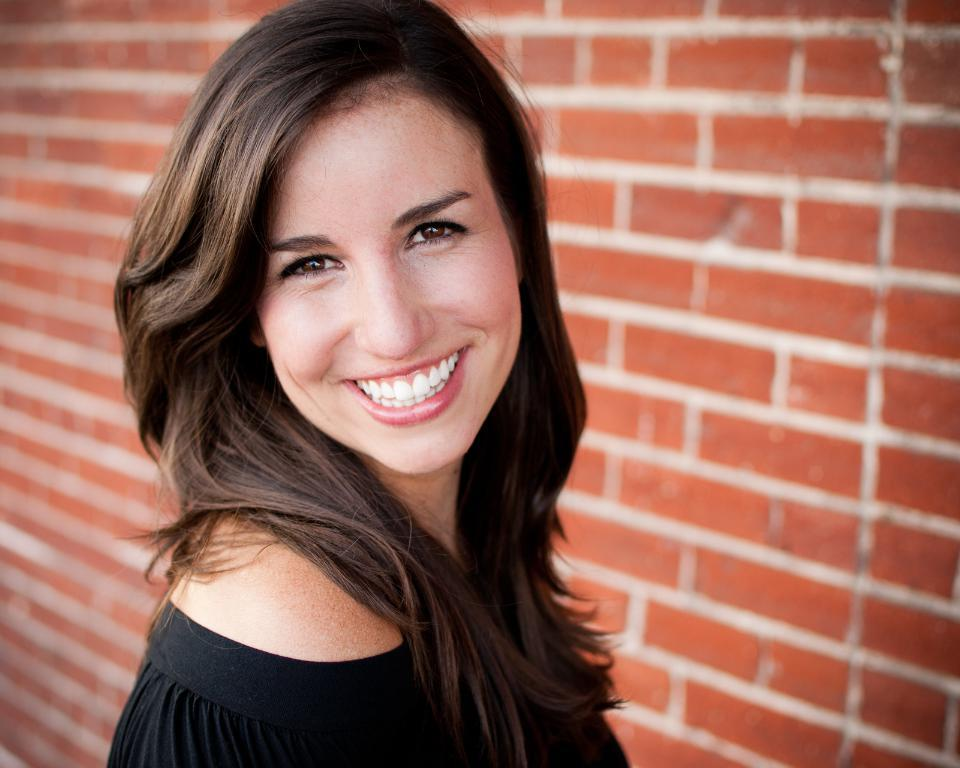Who is present in the image? There is a woman in the image. What is the woman wearing? The woman is wearing a black dress. What is the woman's facial expression? The woman is smiling. What color is the wall in the background of the image? There is a red wall in the background of the image. What type of food is the woman cooking in the image? There is no indication in the image that the woman is cooking any food, so it cannot be determined from the picture. 